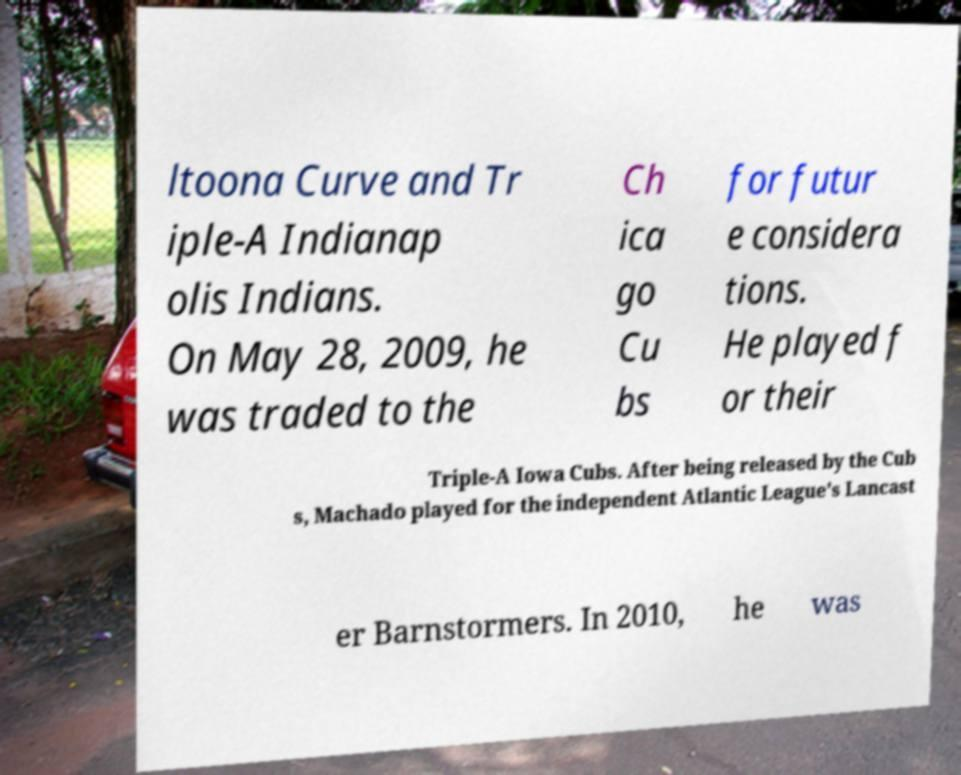Could you extract and type out the text from this image? ltoona Curve and Tr iple-A Indianap olis Indians. On May 28, 2009, he was traded to the Ch ica go Cu bs for futur e considera tions. He played f or their Triple-A Iowa Cubs. After being released by the Cub s, Machado played for the independent Atlantic League's Lancast er Barnstormers. In 2010, he was 